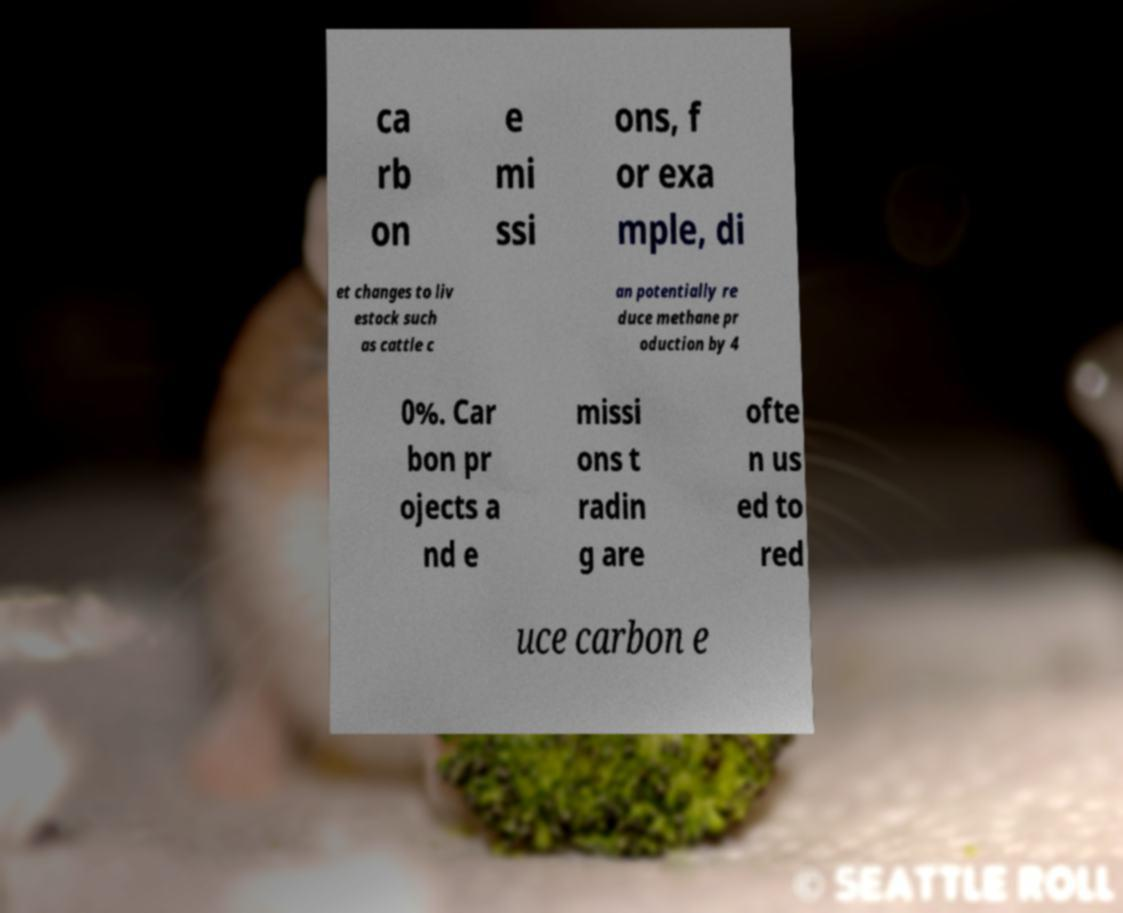Please read and relay the text visible in this image. What does it say? ca rb on e mi ssi ons, f or exa mple, di et changes to liv estock such as cattle c an potentially re duce methane pr oduction by 4 0%. Car bon pr ojects a nd e missi ons t radin g are ofte n us ed to red uce carbon e 